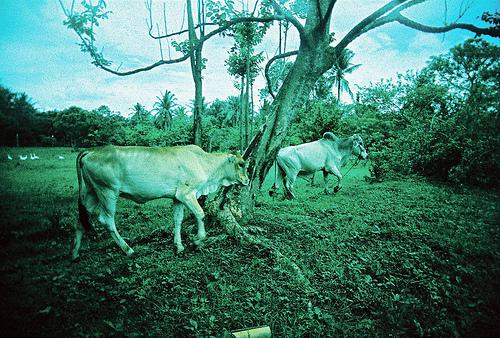Question: what was this picture colored to be?
Choices:
A. Artwork.
B. Yellow.
C. Green.
D. Decoration.
Answer with the letter. Answer: C Question: where was this picture taken?
Choices:
A. In a pasture.
B. The bog.
C. Highlands.
D. Out to sea.
Answer with the letter. Answer: A Question: what is grazing in the pasture?
Choices:
A. Cows.
B. Vultures.
C. Crows and cows.
D. Bulls and geese.
Answer with the letter. Answer: D Question: how many bulls are there?
Choices:
A. Two.
B. Three.
C. Four.
D. Five.
Answer with the letter. Answer: A Question: how many geese are there?
Choices:
A. Six.
B. Seven.
C. Eight.
D. Five.
Answer with the letter. Answer: D Question: what stands between the two bulls?
Choices:
A. A tree.
B. A fence.
C. A farmer.
D. A feeding trough.
Answer with the letter. Answer: A 